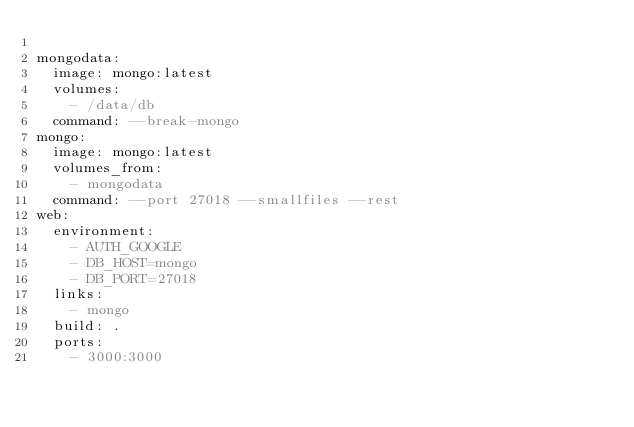Convert code to text. <code><loc_0><loc_0><loc_500><loc_500><_YAML_>
mongodata:
  image: mongo:latest
  volumes:
    - /data/db
  command: --break-mongo
mongo:
  image: mongo:latest
  volumes_from:
    - mongodata
  command: --port 27018 --smallfiles --rest
web:
  environment:
    - AUTH_GOOGLE
    - DB_HOST=mongo
    - DB_PORT=27018
  links:
    - mongo
  build: .
  ports:
    - 3000:3000
</code> 